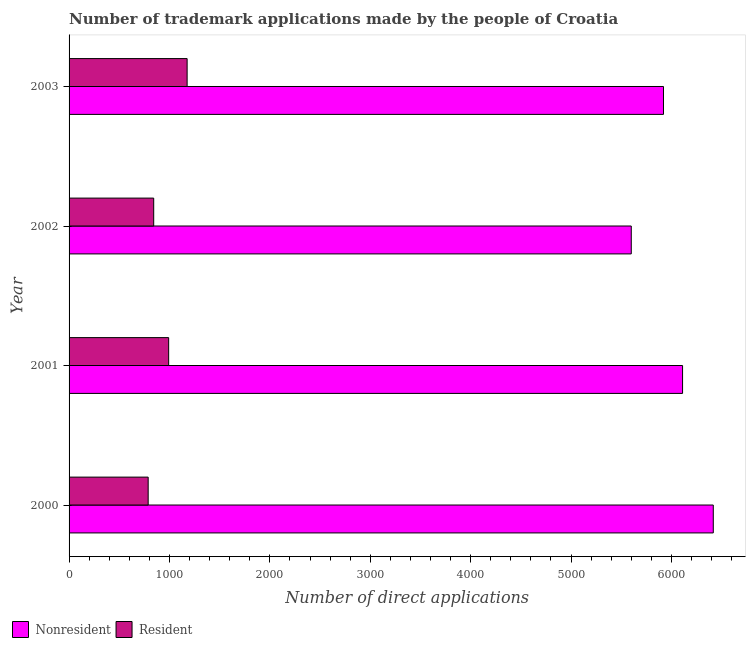How many groups of bars are there?
Ensure brevity in your answer.  4. Are the number of bars per tick equal to the number of legend labels?
Your answer should be compact. Yes. Are the number of bars on each tick of the Y-axis equal?
Provide a succinct answer. Yes. How many bars are there on the 1st tick from the top?
Make the answer very short. 2. What is the number of trademark applications made by non residents in 2002?
Your response must be concise. 5600. Across all years, what is the maximum number of trademark applications made by non residents?
Provide a succinct answer. 6417. Across all years, what is the minimum number of trademark applications made by residents?
Provide a succinct answer. 788. What is the total number of trademark applications made by residents in the graph?
Offer a very short reply. 3799. What is the difference between the number of trademark applications made by residents in 2000 and that in 2002?
Provide a succinct answer. -55. What is the difference between the number of trademark applications made by non residents in 2002 and the number of trademark applications made by residents in 2001?
Provide a succinct answer. 4608. What is the average number of trademark applications made by non residents per year?
Give a very brief answer. 6012.25. In the year 2002, what is the difference between the number of trademark applications made by non residents and number of trademark applications made by residents?
Keep it short and to the point. 4757. What is the ratio of the number of trademark applications made by non residents in 2000 to that in 2003?
Provide a short and direct response. 1.08. Is the difference between the number of trademark applications made by non residents in 2001 and 2002 greater than the difference between the number of trademark applications made by residents in 2001 and 2002?
Your answer should be compact. Yes. What is the difference between the highest and the second highest number of trademark applications made by non residents?
Your answer should be very brief. 306. What is the difference between the highest and the lowest number of trademark applications made by residents?
Your response must be concise. 388. In how many years, is the number of trademark applications made by non residents greater than the average number of trademark applications made by non residents taken over all years?
Ensure brevity in your answer.  2. Is the sum of the number of trademark applications made by residents in 2000 and 2002 greater than the maximum number of trademark applications made by non residents across all years?
Provide a short and direct response. No. What does the 1st bar from the top in 2002 represents?
Ensure brevity in your answer.  Resident. What does the 2nd bar from the bottom in 2002 represents?
Give a very brief answer. Resident. Are all the bars in the graph horizontal?
Offer a very short reply. Yes. How many years are there in the graph?
Provide a short and direct response. 4. Are the values on the major ticks of X-axis written in scientific E-notation?
Your response must be concise. No. What is the title of the graph?
Provide a succinct answer. Number of trademark applications made by the people of Croatia. Does "Stunting" appear as one of the legend labels in the graph?
Ensure brevity in your answer.  No. What is the label or title of the X-axis?
Your response must be concise. Number of direct applications. What is the label or title of the Y-axis?
Offer a very short reply. Year. What is the Number of direct applications of Nonresident in 2000?
Make the answer very short. 6417. What is the Number of direct applications in Resident in 2000?
Offer a terse response. 788. What is the Number of direct applications in Nonresident in 2001?
Offer a very short reply. 6111. What is the Number of direct applications of Resident in 2001?
Your answer should be compact. 992. What is the Number of direct applications in Nonresident in 2002?
Keep it short and to the point. 5600. What is the Number of direct applications in Resident in 2002?
Make the answer very short. 843. What is the Number of direct applications in Nonresident in 2003?
Give a very brief answer. 5921. What is the Number of direct applications in Resident in 2003?
Make the answer very short. 1176. Across all years, what is the maximum Number of direct applications of Nonresident?
Keep it short and to the point. 6417. Across all years, what is the maximum Number of direct applications of Resident?
Provide a succinct answer. 1176. Across all years, what is the minimum Number of direct applications in Nonresident?
Your response must be concise. 5600. Across all years, what is the minimum Number of direct applications in Resident?
Offer a terse response. 788. What is the total Number of direct applications in Nonresident in the graph?
Keep it short and to the point. 2.40e+04. What is the total Number of direct applications of Resident in the graph?
Ensure brevity in your answer.  3799. What is the difference between the Number of direct applications in Nonresident in 2000 and that in 2001?
Provide a short and direct response. 306. What is the difference between the Number of direct applications of Resident in 2000 and that in 2001?
Your response must be concise. -204. What is the difference between the Number of direct applications in Nonresident in 2000 and that in 2002?
Your answer should be very brief. 817. What is the difference between the Number of direct applications of Resident in 2000 and that in 2002?
Give a very brief answer. -55. What is the difference between the Number of direct applications in Nonresident in 2000 and that in 2003?
Offer a terse response. 496. What is the difference between the Number of direct applications of Resident in 2000 and that in 2003?
Make the answer very short. -388. What is the difference between the Number of direct applications in Nonresident in 2001 and that in 2002?
Offer a very short reply. 511. What is the difference between the Number of direct applications in Resident in 2001 and that in 2002?
Ensure brevity in your answer.  149. What is the difference between the Number of direct applications of Nonresident in 2001 and that in 2003?
Give a very brief answer. 190. What is the difference between the Number of direct applications in Resident in 2001 and that in 2003?
Your response must be concise. -184. What is the difference between the Number of direct applications in Nonresident in 2002 and that in 2003?
Give a very brief answer. -321. What is the difference between the Number of direct applications in Resident in 2002 and that in 2003?
Keep it short and to the point. -333. What is the difference between the Number of direct applications of Nonresident in 2000 and the Number of direct applications of Resident in 2001?
Keep it short and to the point. 5425. What is the difference between the Number of direct applications in Nonresident in 2000 and the Number of direct applications in Resident in 2002?
Your answer should be very brief. 5574. What is the difference between the Number of direct applications in Nonresident in 2000 and the Number of direct applications in Resident in 2003?
Provide a short and direct response. 5241. What is the difference between the Number of direct applications of Nonresident in 2001 and the Number of direct applications of Resident in 2002?
Provide a short and direct response. 5268. What is the difference between the Number of direct applications of Nonresident in 2001 and the Number of direct applications of Resident in 2003?
Make the answer very short. 4935. What is the difference between the Number of direct applications of Nonresident in 2002 and the Number of direct applications of Resident in 2003?
Make the answer very short. 4424. What is the average Number of direct applications in Nonresident per year?
Provide a succinct answer. 6012.25. What is the average Number of direct applications of Resident per year?
Your answer should be very brief. 949.75. In the year 2000, what is the difference between the Number of direct applications in Nonresident and Number of direct applications in Resident?
Offer a terse response. 5629. In the year 2001, what is the difference between the Number of direct applications of Nonresident and Number of direct applications of Resident?
Make the answer very short. 5119. In the year 2002, what is the difference between the Number of direct applications of Nonresident and Number of direct applications of Resident?
Offer a terse response. 4757. In the year 2003, what is the difference between the Number of direct applications in Nonresident and Number of direct applications in Resident?
Your answer should be compact. 4745. What is the ratio of the Number of direct applications in Nonresident in 2000 to that in 2001?
Give a very brief answer. 1.05. What is the ratio of the Number of direct applications of Resident in 2000 to that in 2001?
Offer a terse response. 0.79. What is the ratio of the Number of direct applications of Nonresident in 2000 to that in 2002?
Offer a very short reply. 1.15. What is the ratio of the Number of direct applications of Resident in 2000 to that in 2002?
Provide a succinct answer. 0.93. What is the ratio of the Number of direct applications in Nonresident in 2000 to that in 2003?
Your answer should be very brief. 1.08. What is the ratio of the Number of direct applications of Resident in 2000 to that in 2003?
Your answer should be compact. 0.67. What is the ratio of the Number of direct applications in Nonresident in 2001 to that in 2002?
Make the answer very short. 1.09. What is the ratio of the Number of direct applications in Resident in 2001 to that in 2002?
Your answer should be compact. 1.18. What is the ratio of the Number of direct applications in Nonresident in 2001 to that in 2003?
Give a very brief answer. 1.03. What is the ratio of the Number of direct applications in Resident in 2001 to that in 2003?
Your answer should be compact. 0.84. What is the ratio of the Number of direct applications in Nonresident in 2002 to that in 2003?
Provide a succinct answer. 0.95. What is the ratio of the Number of direct applications in Resident in 2002 to that in 2003?
Keep it short and to the point. 0.72. What is the difference between the highest and the second highest Number of direct applications in Nonresident?
Offer a terse response. 306. What is the difference between the highest and the second highest Number of direct applications of Resident?
Ensure brevity in your answer.  184. What is the difference between the highest and the lowest Number of direct applications in Nonresident?
Your response must be concise. 817. What is the difference between the highest and the lowest Number of direct applications of Resident?
Offer a terse response. 388. 